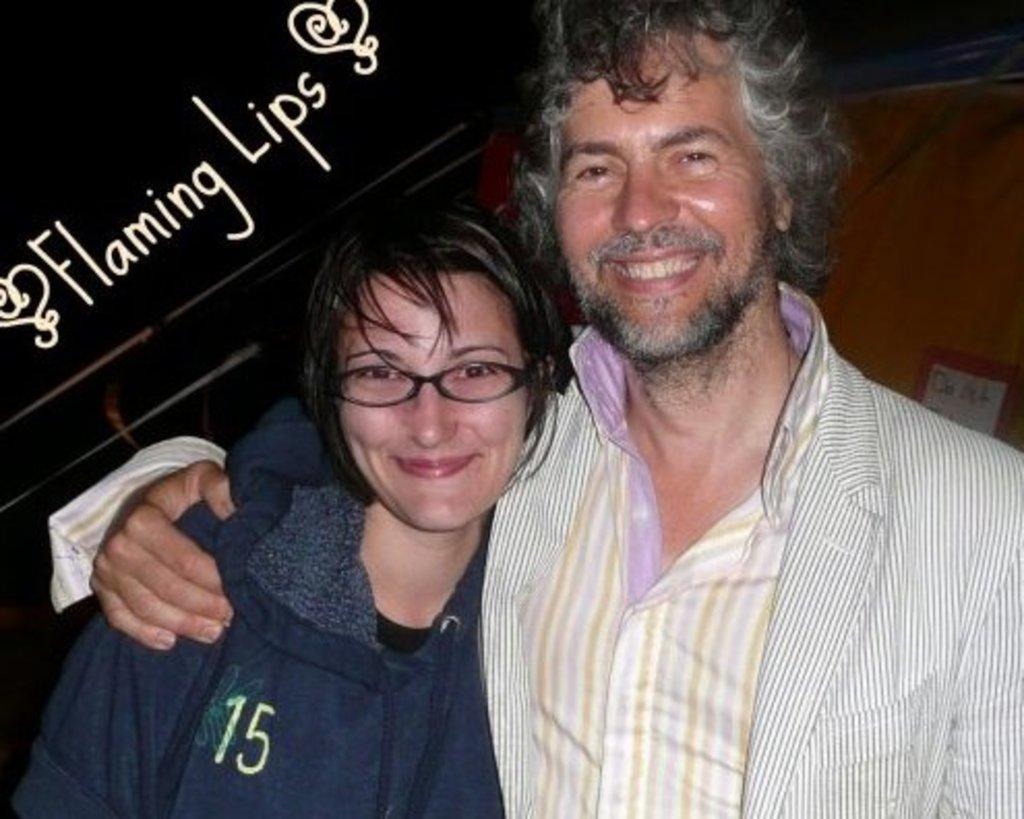Please provide a concise description of this image. On the right side, there is a person in a shirt, smiling and holding a shoulder of a woman who is wearing a spectacle. On the top left, there is a watermark. And the background is dark in color. 